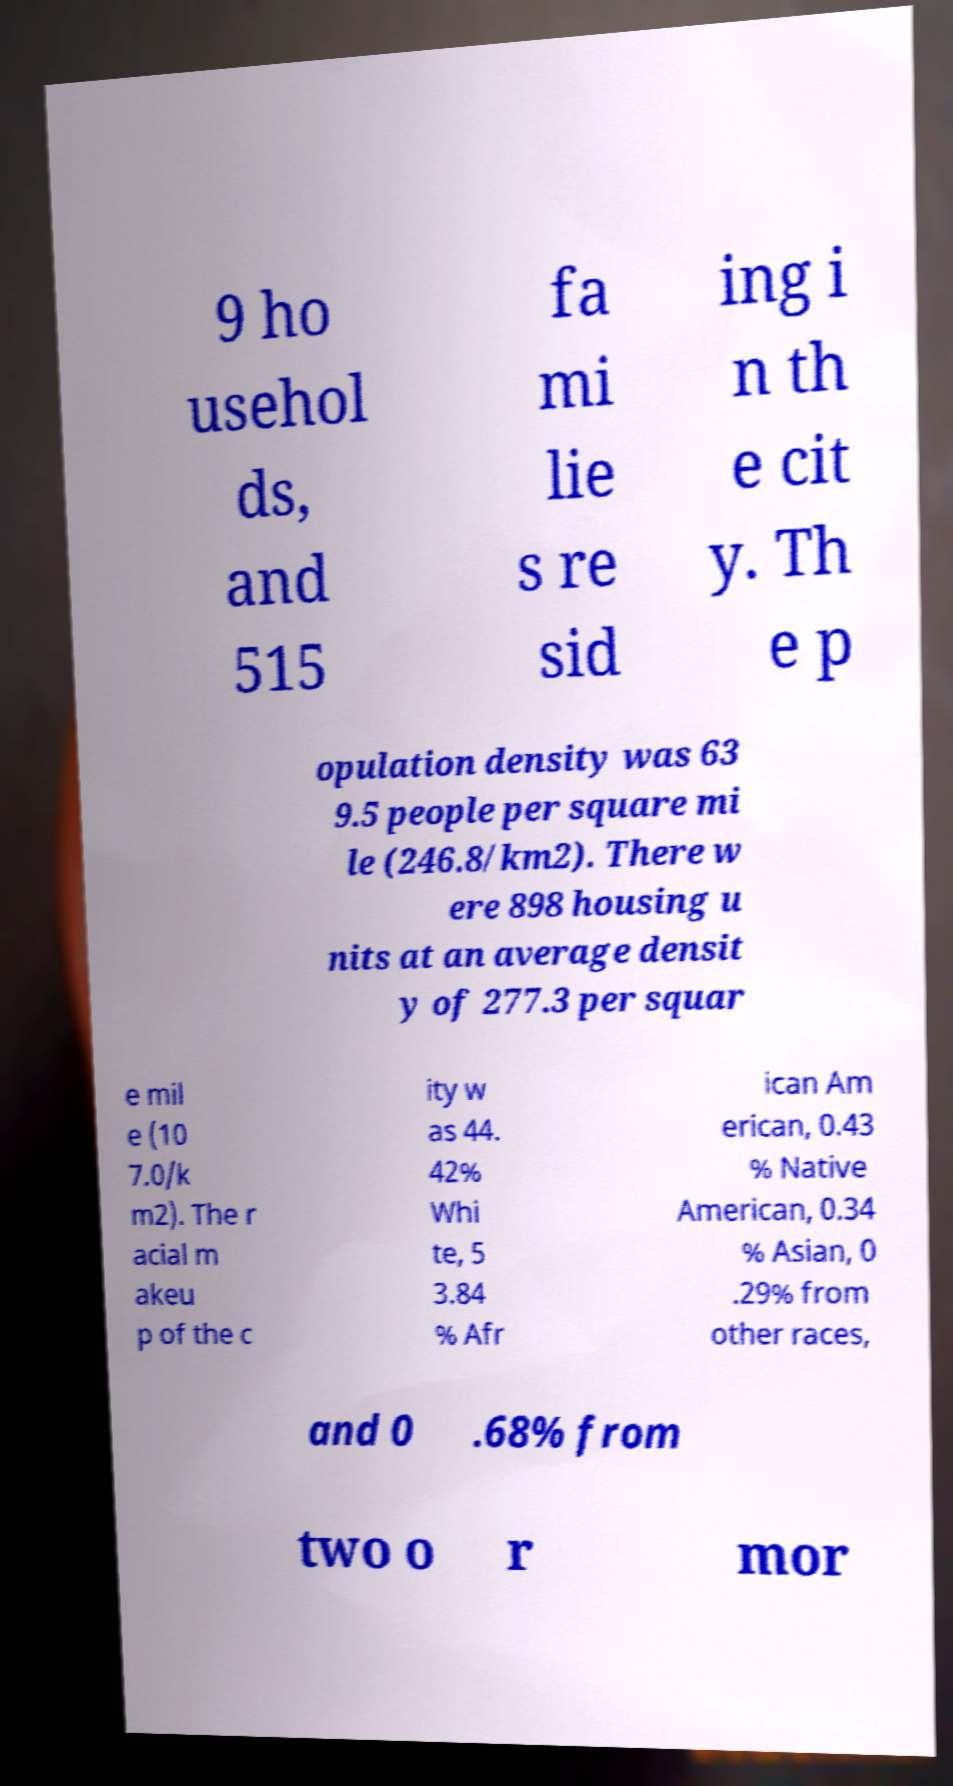For documentation purposes, I need the text within this image transcribed. Could you provide that? 9 ho usehol ds, and 515 fa mi lie s re sid ing i n th e cit y. Th e p opulation density was 63 9.5 people per square mi le (246.8/km2). There w ere 898 housing u nits at an average densit y of 277.3 per squar e mil e (10 7.0/k m2). The r acial m akeu p of the c ity w as 44. 42% Whi te, 5 3.84 % Afr ican Am erican, 0.43 % Native American, 0.34 % Asian, 0 .29% from other races, and 0 .68% from two o r mor 